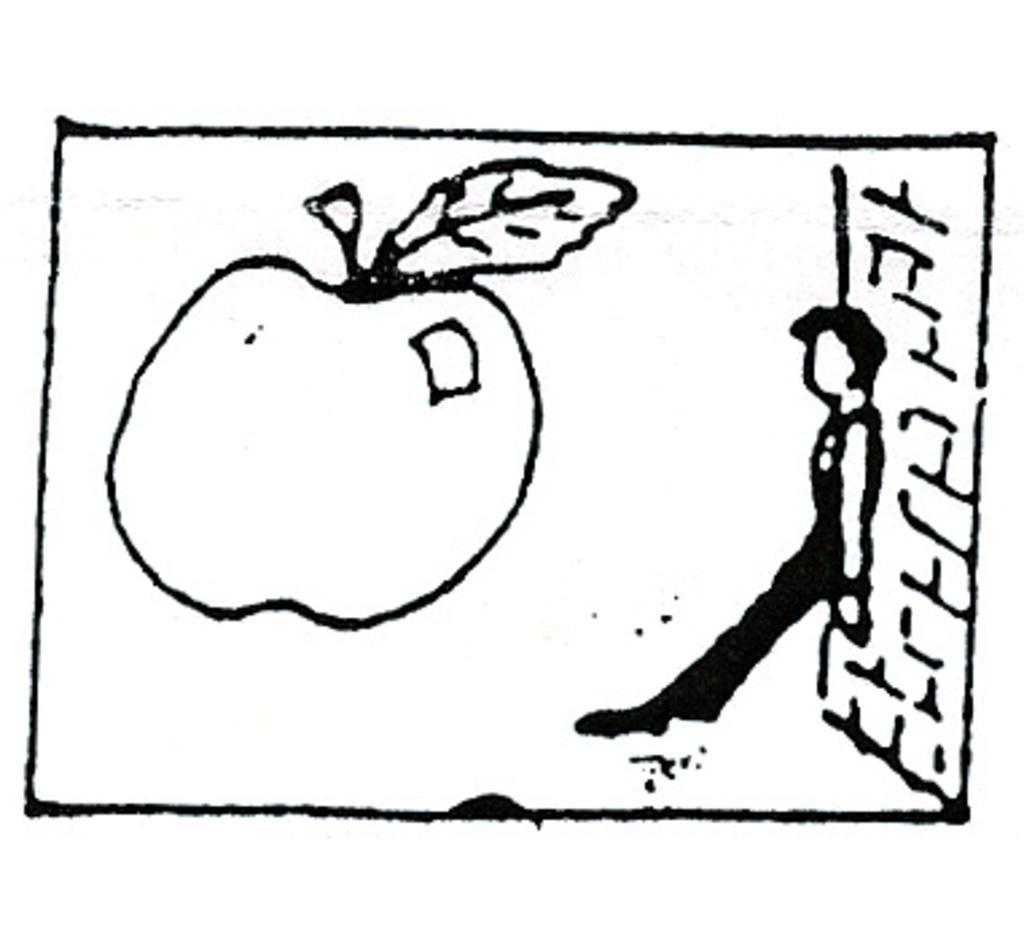Please provide a concise description of this image. In this image I can see on the left side there is the sketch of an apple. On the right side a person is leaning to the wall. 